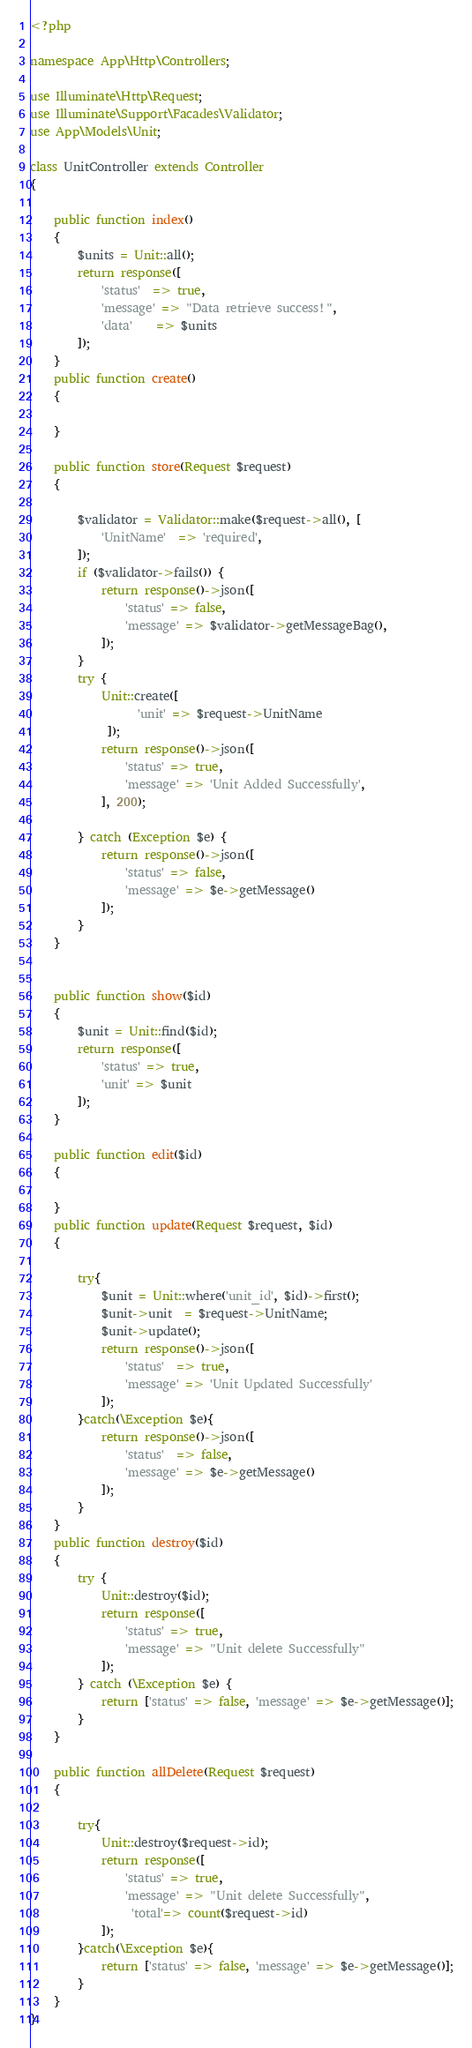Convert code to text. <code><loc_0><loc_0><loc_500><loc_500><_PHP_><?php

namespace App\Http\Controllers;

use Illuminate\Http\Request;
use Illuminate\Support\Facades\Validator;
use App\Models\Unit;

class UnitController extends Controller
{
    
    public function index()
    {
        $units = Unit::all();
        return response([
            'status'  => true,
            'message' => "Data retrieve success!",
            'data'    => $units
        ]);
    }
    public function create()
    {

    }

    public function store(Request $request)
    {
        
        $validator = Validator::make($request->all(), [
            'UnitName'  => 'required',
        ]);
        if ($validator->fails()) {
            return response()->json([
                'status' => false,
                'message' => $validator->getMessageBag(),
            ]);
        }
        try {
            Unit::create([
                  'unit' => $request->UnitName
             ]);
            return response()->json([
                'status' => true,
                'message' => 'Unit Added Successfully',
            ], 200);

        } catch (Exception $e) {
            return response()->json([
                'status' => false,
                'message' => $e->getMessage()
            ]);
        }
    }


    public function show($id)
    {
        $unit = Unit::find($id);
        return response([
            'status' => true,
            'unit' => $unit
        ]);
    }

    public function edit($id)
    {

    }
    public function update(Request $request, $id)
    {

        try{
            $unit = Unit::where('unit_id', $id)->first();
            $unit->unit  = $request->UnitName;
            $unit->update();
            return response()->json([
                'status'  => true,
                'message' => 'Unit Updated Successfully'
            ]);
        }catch(\Exception $e){
            return response()->json([
                'status'  => false,
                'message' => $e->getMessage()
            ]);
        }
    }
    public function destroy($id)
    {
        try {
            Unit::destroy($id);
            return response([
                'status' => true,
                'message' => "Unit delete Successfully"
            ]);
        } catch (\Exception $e) {
            return ['status' => false, 'message' => $e->getMessage()];
        }
    }

    public function allDelete(Request $request)
    {
        
        try{
            Unit::destroy($request->id);
            return response([
                'status' => true,
                'message' => "Unit delete Successfully",
                 'total'=> count($request->id)
            ]);
        }catch(\Exception $e){
            return ['status' => false, 'message' => $e->getMessage()];
        }
    }
}
</code> 